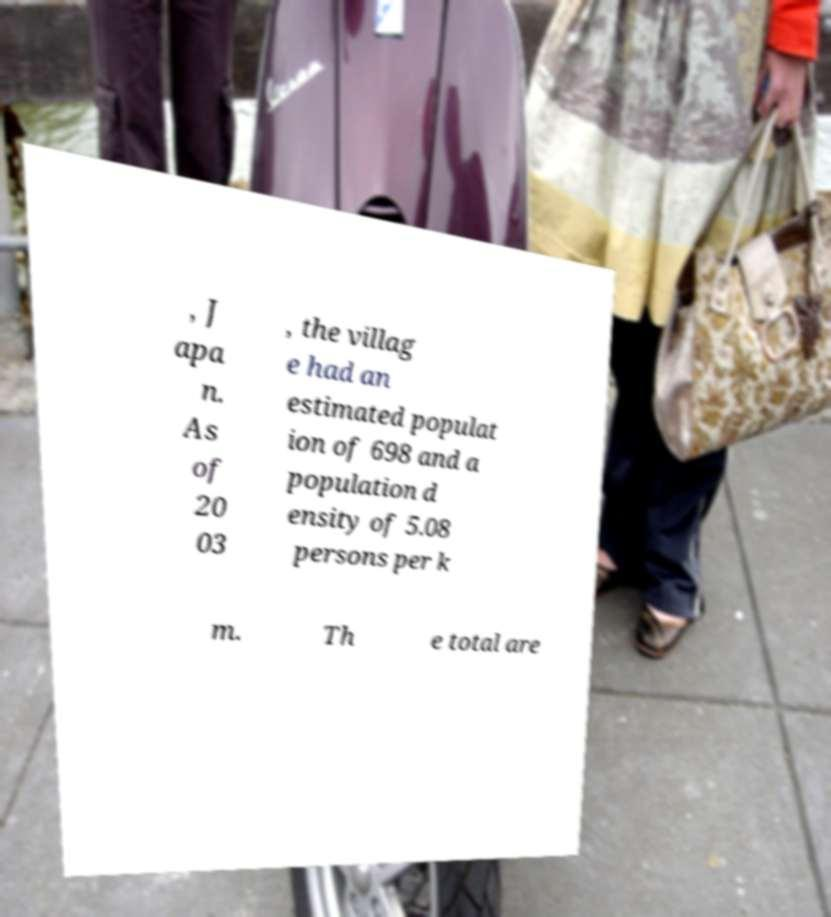Can you accurately transcribe the text from the provided image for me? , J apa n. As of 20 03 , the villag e had an estimated populat ion of 698 and a population d ensity of 5.08 persons per k m. Th e total are 